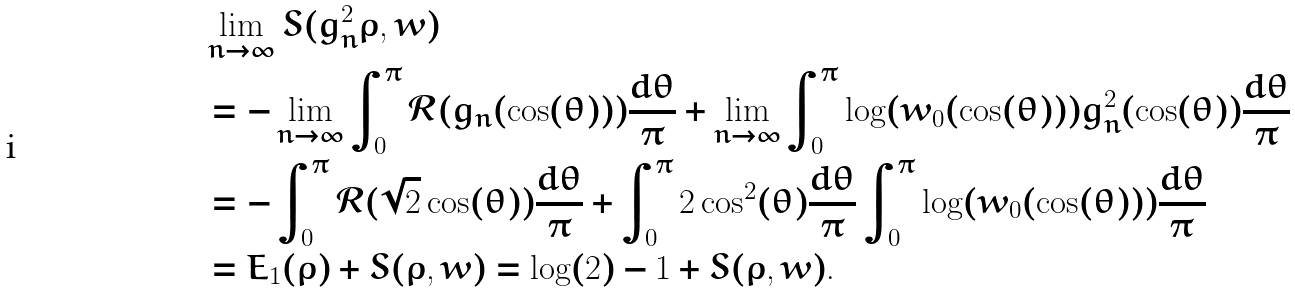<formula> <loc_0><loc_0><loc_500><loc_500>& \lim _ { n \to \infty } S ( g _ { n } ^ { 2 } \rho , w ) \\ & = - \lim _ { n \to \infty } \int _ { 0 } ^ { \pi } \mathcal { R } ( g _ { n } ( \cos ( \theta ) ) ) \frac { d \theta } { \pi } + \lim _ { n \to \infty } \int _ { 0 } ^ { \pi } \log ( w _ { 0 } ( \cos ( \theta ) ) ) g _ { n } ^ { 2 } ( \cos ( \theta ) ) \frac { d \theta } { \pi } \\ & = - \int _ { 0 } ^ { \pi } \mathcal { R } ( \sqrt { 2 } \cos ( \theta ) ) \frac { d \theta } { \pi } + \int _ { 0 } ^ { \pi } 2 \cos ^ { 2 } ( \theta ) \frac { d \theta } { \pi } \int _ { 0 } ^ { \pi } \log ( w _ { 0 } ( \cos ( \theta ) ) ) \frac { d \theta } { \pi } \\ & = E _ { 1 } ( \rho ) + S ( \rho , w ) = \log ( 2 ) - 1 + S ( \rho , w ) .</formula> 